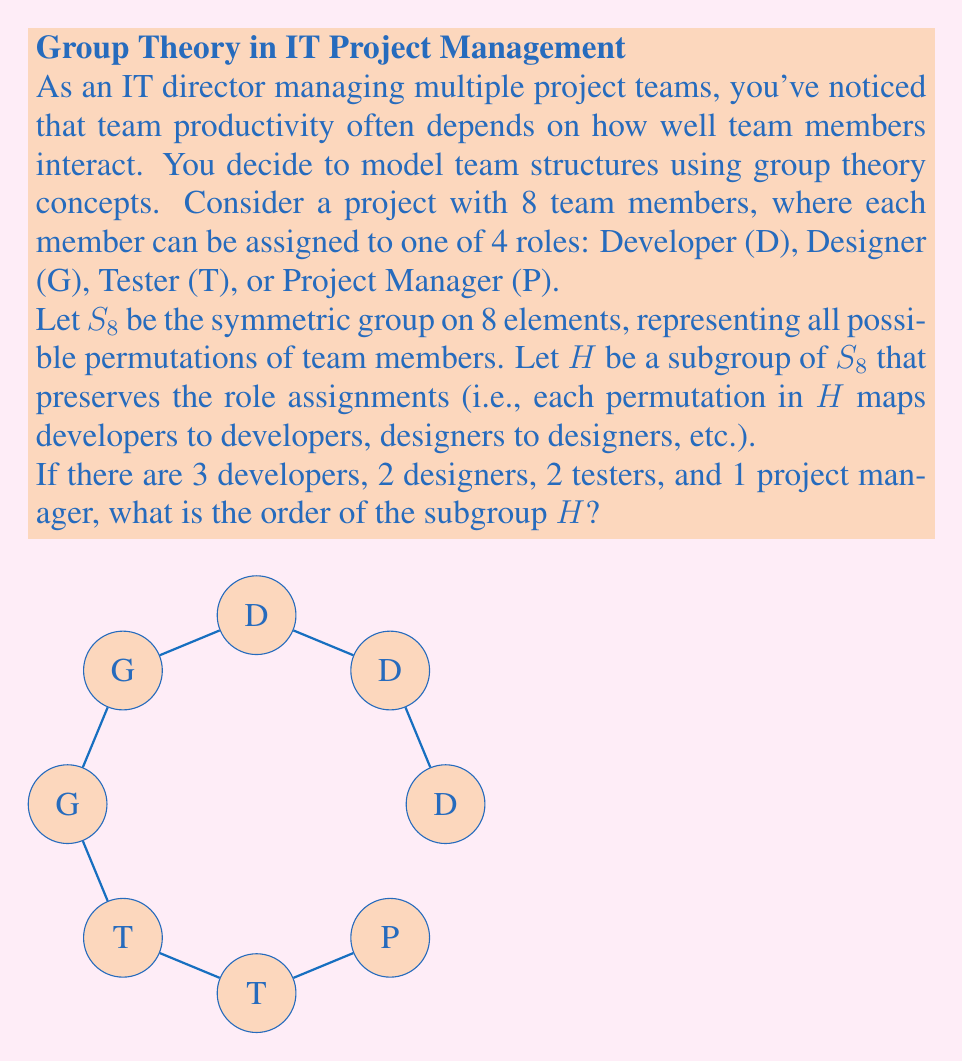Can you answer this question? Let's approach this step-by-step:

1) The subgroup $H$ consists of permutations that preserve the role assignments. This means we can permute team members within their roles, but not between different roles.

2) We can break this down by considering the permutations possible within each role:
   - For 3 developers: There are 3! = 6 possible permutations
   - For 2 designers: There are 2! = 2 possible permutations
   - For 2 testers: There are 2! = 2 possible permutations
   - For 1 project manager: There is only 1! = 1 permutation (no change)

3) By the fundamental counting principle, the total number of permutations in $H$ is the product of the number of permutations for each role:

   $|H| = 3! \cdot 2! \cdot 2! \cdot 1!$

4) Let's calculate this:
   $|H| = 6 \cdot 2 \cdot 2 \cdot 1 = 24$

Therefore, the order of the subgroup $H$ is 24.

This result has a practical interpretation: there are 24 different ways to rearrange the team members while keeping their role assignments intact. As an IT director, this gives you an idea of the flexibility within your current team structure.
Answer: 24 